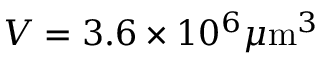Convert formula to latex. <formula><loc_0><loc_0><loc_500><loc_500>V = 3 . 6 \times 1 0 ^ { 6 } \mu m ^ { 3 }</formula> 